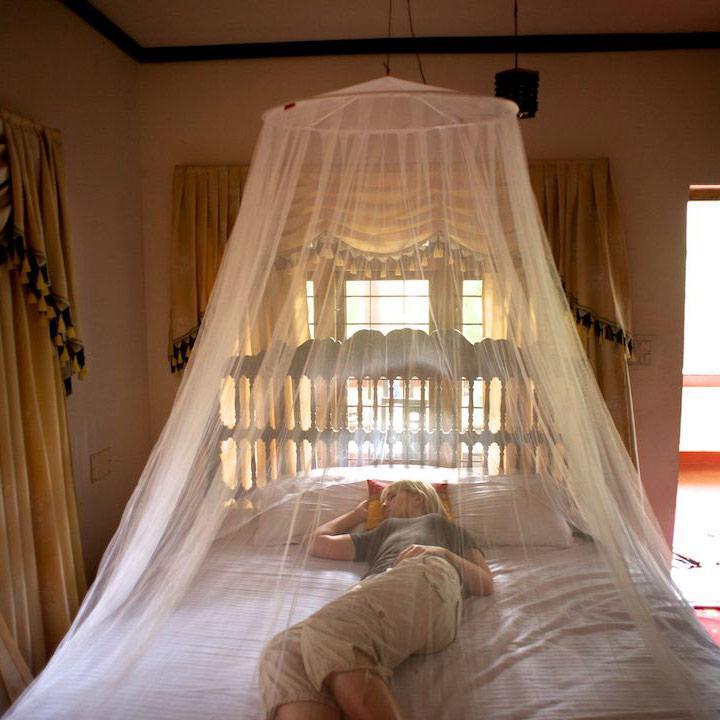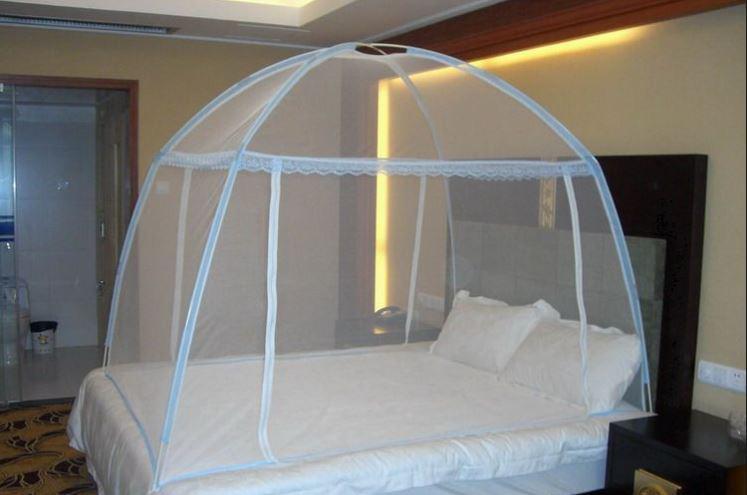The first image is the image on the left, the second image is the image on the right. Assess this claim about the two images: "The right image shows a dome-shaped bed enclosure.". Correct or not? Answer yes or no. Yes. 